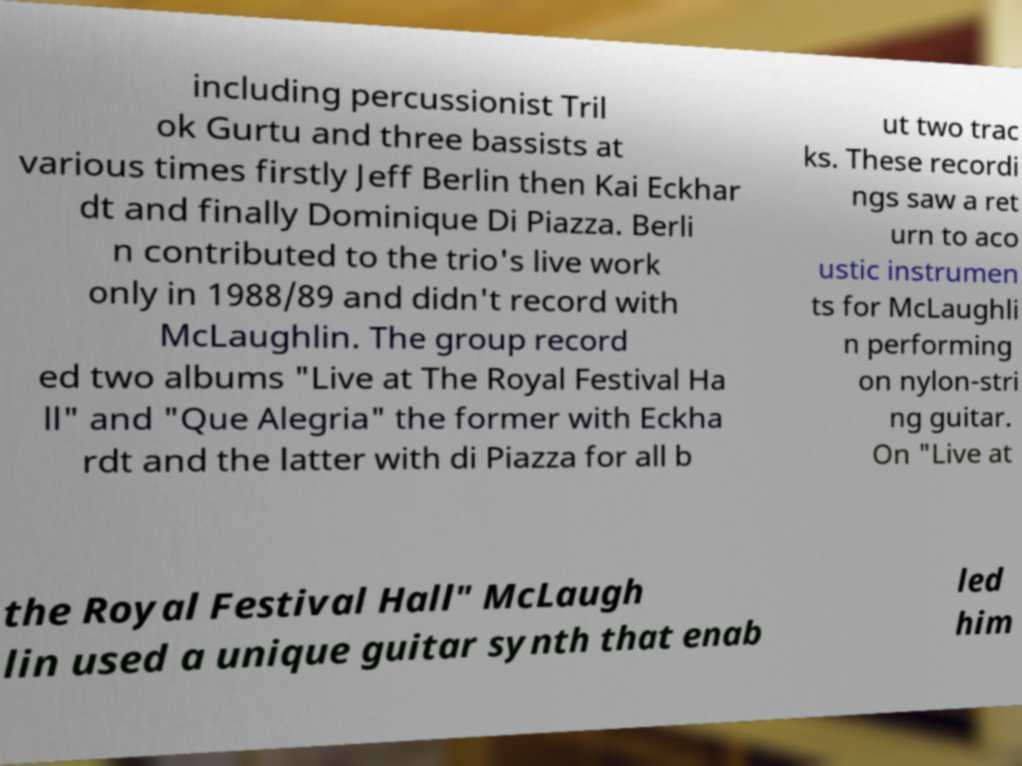There's text embedded in this image that I need extracted. Can you transcribe it verbatim? including percussionist Tril ok Gurtu and three bassists at various times firstly Jeff Berlin then Kai Eckhar dt and finally Dominique Di Piazza. Berli n contributed to the trio's live work only in 1988/89 and didn't record with McLaughlin. The group record ed two albums "Live at The Royal Festival Ha ll" and "Que Alegria" the former with Eckha rdt and the latter with di Piazza for all b ut two trac ks. These recordi ngs saw a ret urn to aco ustic instrumen ts for McLaughli n performing on nylon-stri ng guitar. On "Live at the Royal Festival Hall" McLaugh lin used a unique guitar synth that enab led him 